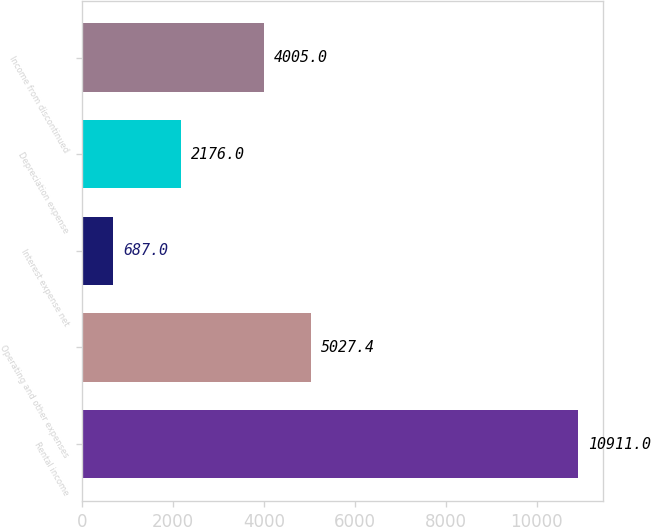Convert chart. <chart><loc_0><loc_0><loc_500><loc_500><bar_chart><fcel>Rental income<fcel>Operating and other expenses<fcel>Interest expense net<fcel>Depreciation expense<fcel>Income from discontinued<nl><fcel>10911<fcel>5027.4<fcel>687<fcel>2176<fcel>4005<nl></chart> 